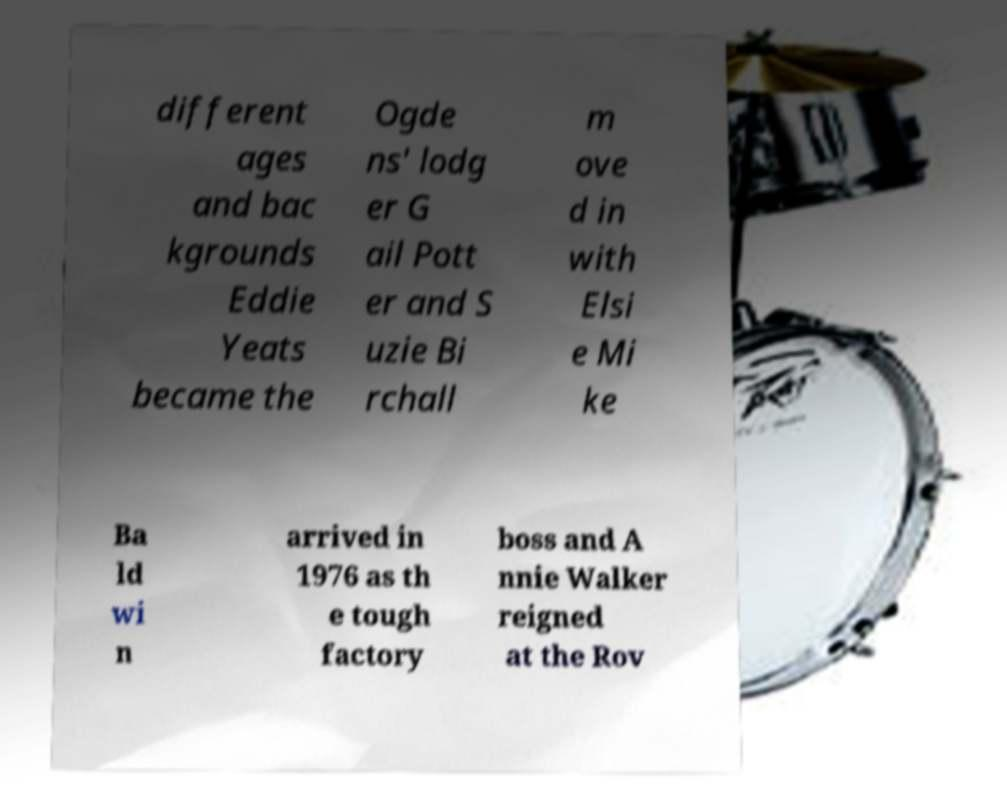For documentation purposes, I need the text within this image transcribed. Could you provide that? different ages and bac kgrounds Eddie Yeats became the Ogde ns' lodg er G ail Pott er and S uzie Bi rchall m ove d in with Elsi e Mi ke Ba ld wi n arrived in 1976 as th e tough factory boss and A nnie Walker reigned at the Rov 